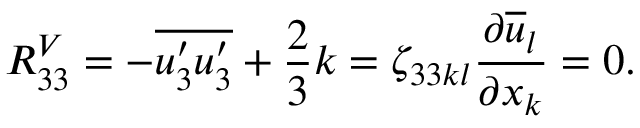<formula> <loc_0><loc_0><loc_500><loc_500>R _ { 3 3 } ^ { V } = - \overline { { u _ { 3 } ^ { \prime } u _ { 3 } ^ { \prime } } } + \frac { 2 } { 3 } k = \zeta _ { 3 3 k l } \frac { \partial \overline { u } _ { l } } { \partial x _ { k } } = 0 .</formula> 